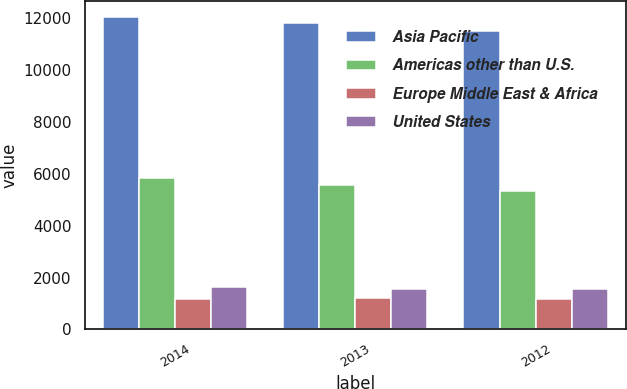<chart> <loc_0><loc_0><loc_500><loc_500><stacked_bar_chart><ecel><fcel>2014<fcel>2013<fcel>2012<nl><fcel>Asia Pacific<fcel>12045<fcel>11815<fcel>11514<nl><fcel>Americas other than U.S.<fcel>5824<fcel>5574<fcel>5336<nl><fcel>Europe Middle East & Africa<fcel>1176<fcel>1214<fcel>1190<nl><fcel>United States<fcel>1623<fcel>1544<fcel>1541<nl></chart> 